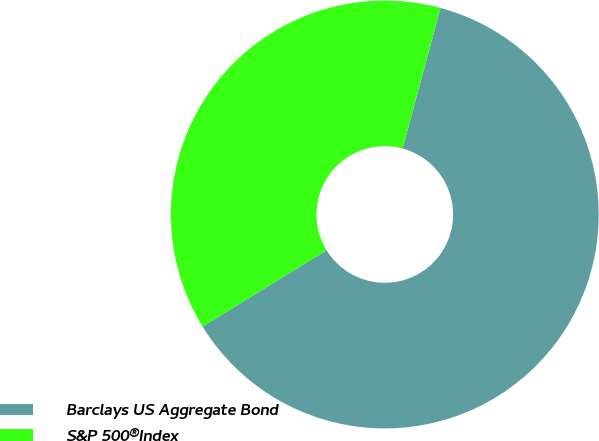<chart> <loc_0><loc_0><loc_500><loc_500><pie_chart><fcel>Barclays US Aggregate Bond<fcel>S&P 500®Index<nl><fcel>62.03%<fcel>37.97%<nl></chart> 